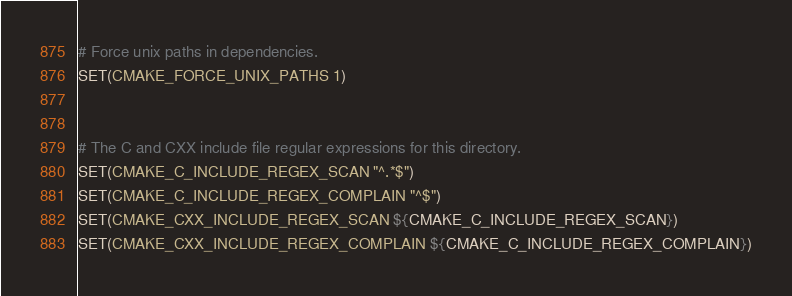Convert code to text. <code><loc_0><loc_0><loc_500><loc_500><_CMake_>
# Force unix paths in dependencies.
SET(CMAKE_FORCE_UNIX_PATHS 1)


# The C and CXX include file regular expressions for this directory.
SET(CMAKE_C_INCLUDE_REGEX_SCAN "^.*$")
SET(CMAKE_C_INCLUDE_REGEX_COMPLAIN "^$")
SET(CMAKE_CXX_INCLUDE_REGEX_SCAN ${CMAKE_C_INCLUDE_REGEX_SCAN})
SET(CMAKE_CXX_INCLUDE_REGEX_COMPLAIN ${CMAKE_C_INCLUDE_REGEX_COMPLAIN})
</code> 